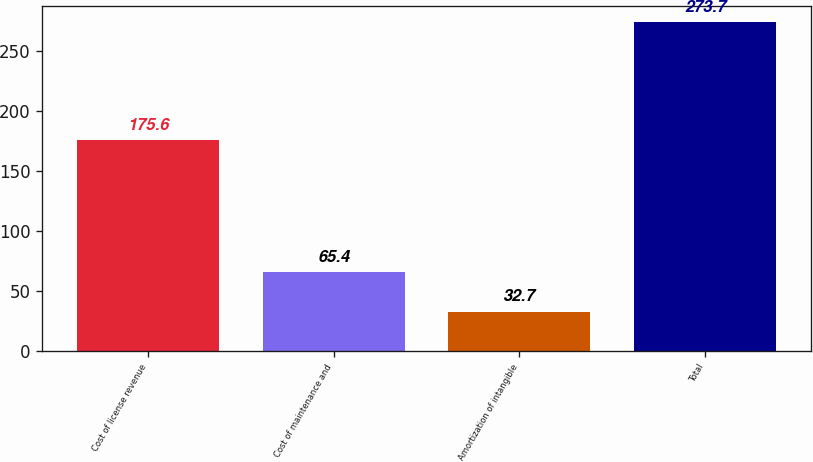Convert chart to OTSL. <chart><loc_0><loc_0><loc_500><loc_500><bar_chart><fcel>Cost of license revenue<fcel>Cost of maintenance and<fcel>Amortization of intangible<fcel>Total<nl><fcel>175.6<fcel>65.4<fcel>32.7<fcel>273.7<nl></chart> 